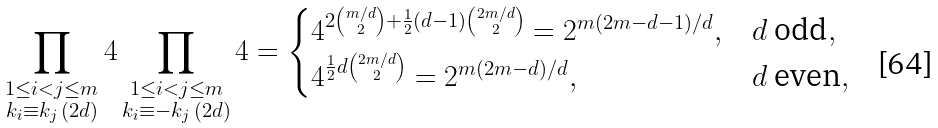Convert formula to latex. <formula><loc_0><loc_0><loc_500><loc_500>\prod _ { \substack { 1 \leq i < j \leq m \\ k _ { i } \equiv k _ { j } \, ( 2 d ) } } 4 \prod _ { \substack { 1 \leq i < j \leq m \\ k _ { i } \equiv - k _ { j } \, ( 2 d ) } } 4 = \begin{cases} 4 ^ { 2 \binom { m / d } { 2 } + \frac { 1 } { 2 } ( d - 1 ) \binom { 2 m / d } { 2 } } = 2 ^ { m ( 2 m - d - 1 ) / d } , & d \text { odd} , \\ 4 ^ { \frac { 1 } { 2 } d \binom { 2 m / d } { 2 } } = 2 ^ { m ( 2 m - d ) / d } , & d \text { even} , \end{cases}</formula> 